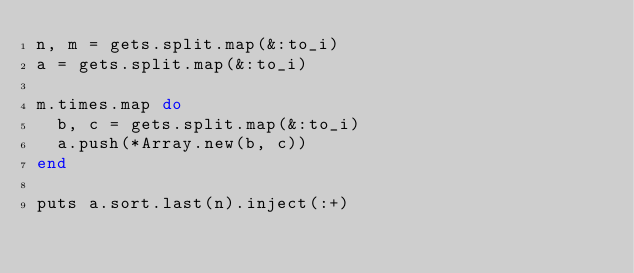Convert code to text. <code><loc_0><loc_0><loc_500><loc_500><_Ruby_>n, m = gets.split.map(&:to_i)
a = gets.split.map(&:to_i)

m.times.map do
  b, c = gets.split.map(&:to_i)
  a.push(*Array.new(b, c))
end

puts a.sort.last(n).inject(:+)
</code> 